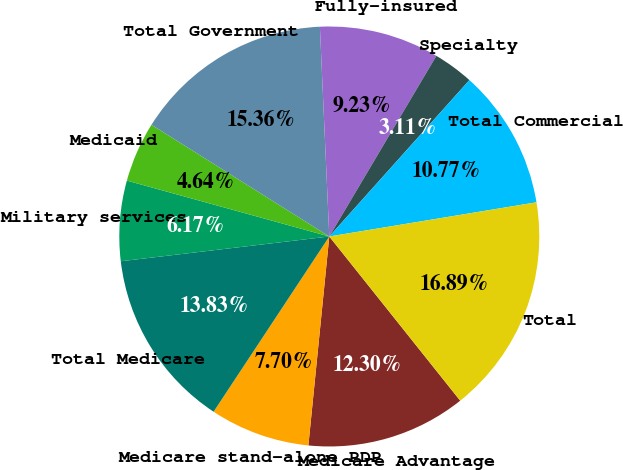Convert chart. <chart><loc_0><loc_0><loc_500><loc_500><pie_chart><fcel>Medicare Advantage<fcel>Medicare stand-alone PDP<fcel>Total Medicare<fcel>Military services<fcel>Medicaid<fcel>Total Government<fcel>Fully-insured<fcel>Specialty<fcel>Total Commercial<fcel>Total<nl><fcel>12.3%<fcel>7.7%<fcel>13.83%<fcel>6.17%<fcel>4.64%<fcel>15.36%<fcel>9.23%<fcel>3.11%<fcel>10.77%<fcel>16.89%<nl></chart> 